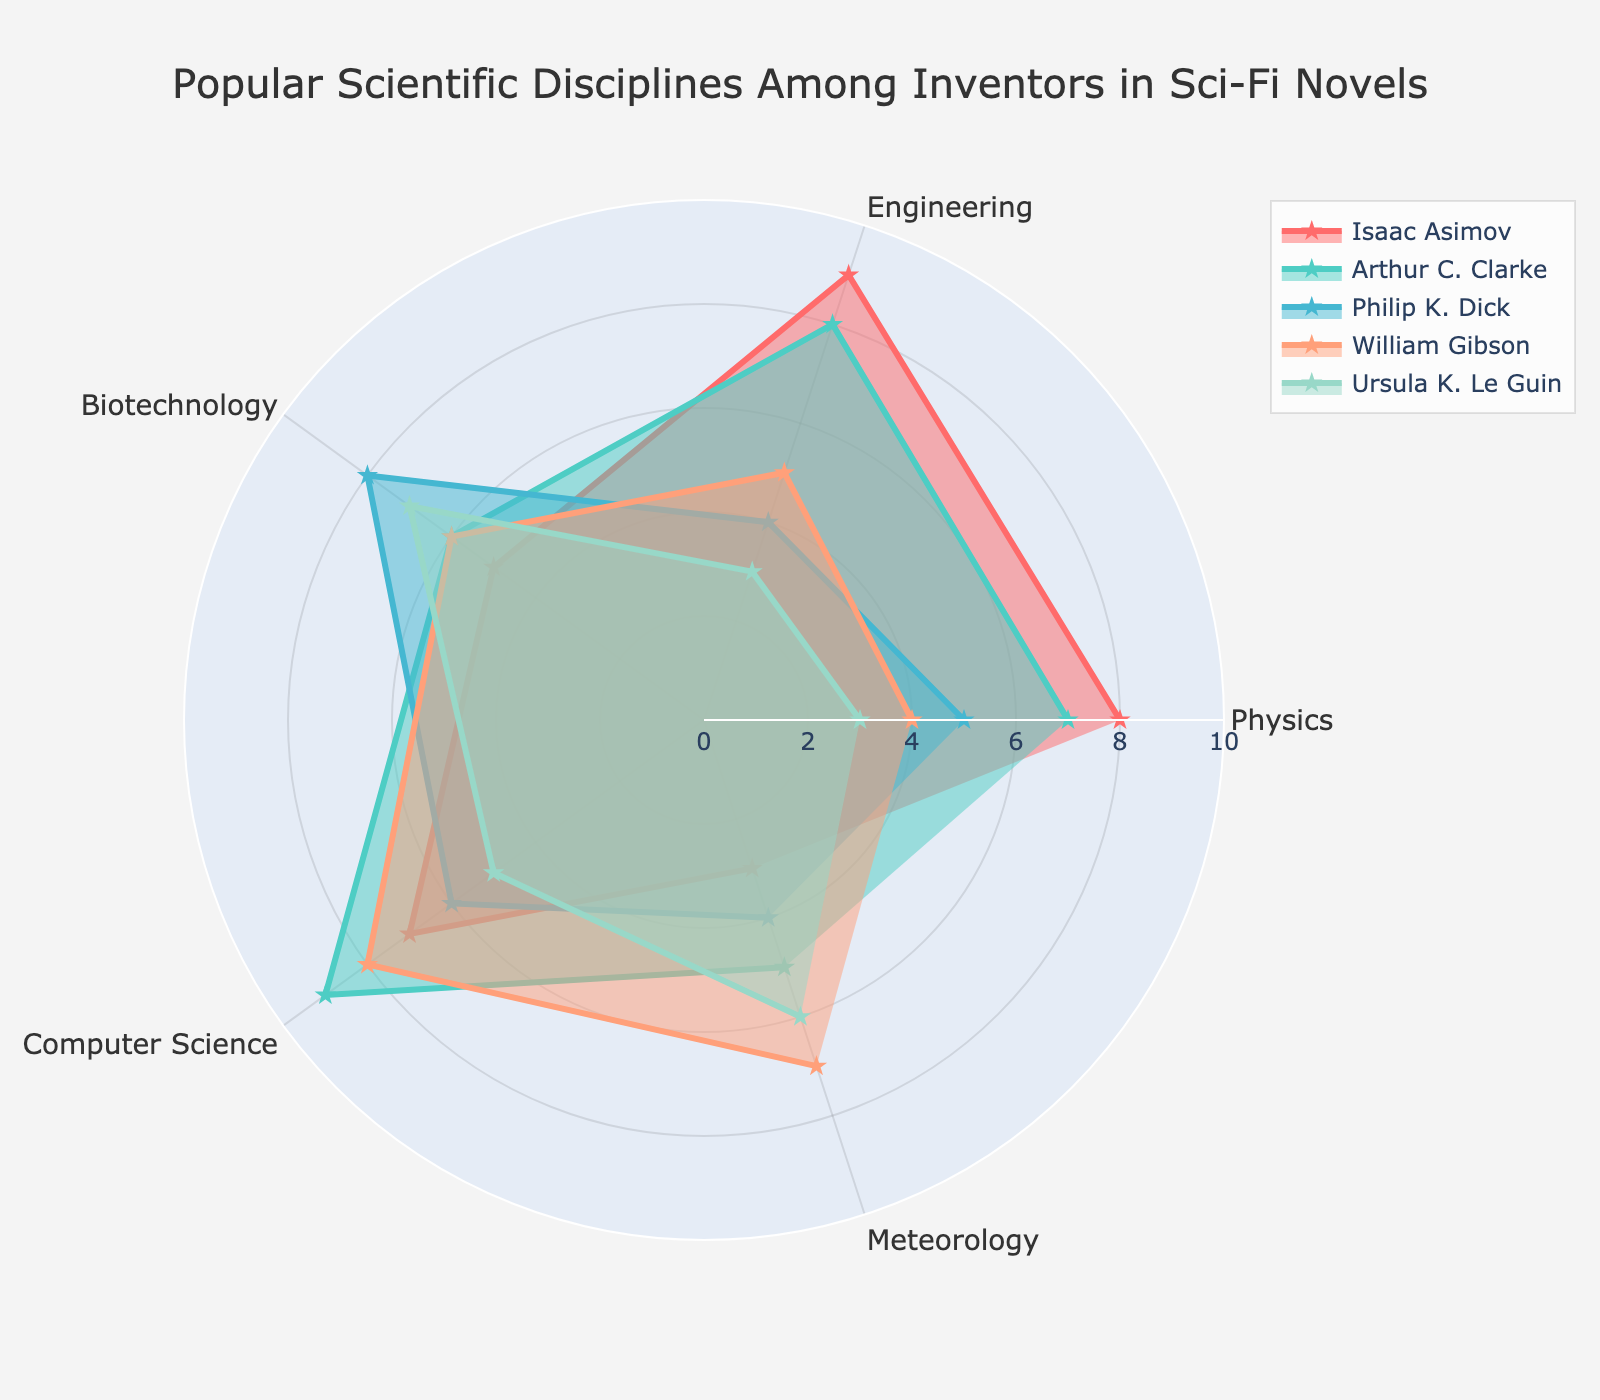What's the title of the radar chart? The title is located at the top center of the radar chart, which is designed to give viewers an immediate understanding of the chart's focus.
Answer: Popular Scientific Disciplines Among Inventors in Sci-Fi Novels Which scientific discipline has the highest value for Isaac Asimov? Look for Isaac Asimov's data points on the radar chart and identify the one with the longest stretch from the center.
Answer: Engineering What's the difference between Arthur C. Clarke's and Ursula K. Le Guin's scores in Computer Science? Locate the values for Computer Science for both Arthur C. Clarke and Ursula K. Le Guin and subtract Ursula K. Le Guin's score from Arthur C. Clarke's score.
Answer: 4 Which two authors have similar scores in Meteorology? Look at the Meteorology data points for all authors and identify the two whose points are closest to each other.
Answer: William Gibson and Ursula K. Le Guin Which scientific discipline shows the most variation among the authors? Compare the lengths of the lines for each scientific discipline across all authors to find the one with the largest range of values.
Answer: Physics What is the average score of Biotechnology for all authors? Add up the Biotechnology scores for all authors and divide by the number of authors (5).
Answer: 6.4 Which author has the most balanced (similar) scores across all scientific disciplines? Look for the author whose radar chart area appears most uniform or equidistant from the center in all directions.
Answer: Ursula K. Le Guin By how much does Philip K. Dick's Engineering score exceed his Meteorology score? Subtract Philip K. Dick's Meteorology score from his Engineering score.
Answer: 0 Of all disciplines, which one is least popular among all authors combined? Combine the scores of all authors for each discipline and find the one with the lowest total value.
Answer: Meteorology Between William Gibson and Isaac Asimov, who has a higher score in Physics and by how much? Compare the Physics scores for William Gibson and Isaac Asimov and find the difference by subtracting the lower score from the higher one.
Answer: Isaac Asimov by 4 